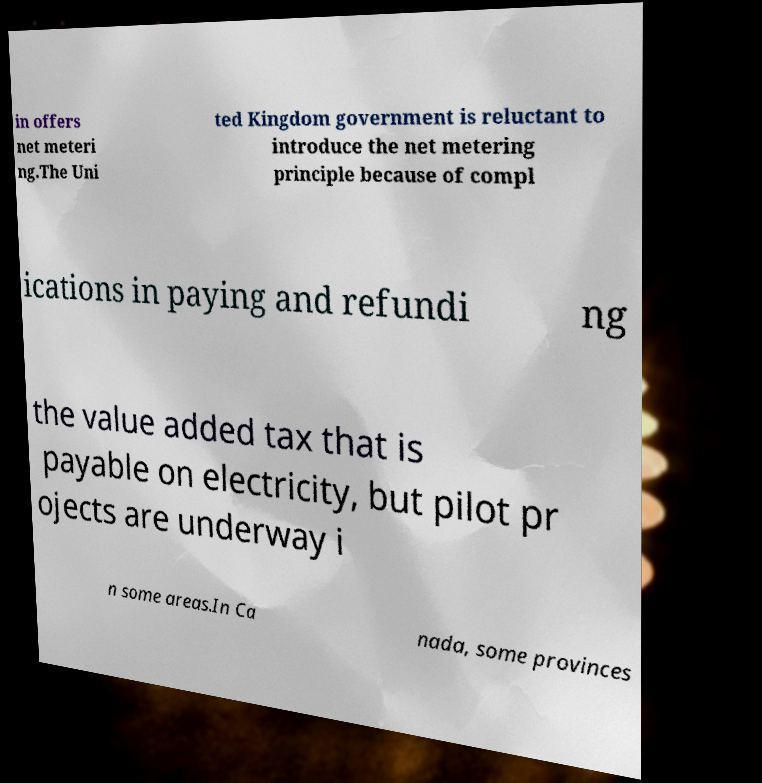I need the written content from this picture converted into text. Can you do that? in offers net meteri ng.The Uni ted Kingdom government is reluctant to introduce the net metering principle because of compl ications in paying and refundi ng the value added tax that is payable on electricity, but pilot pr ojects are underway i n some areas.In Ca nada, some provinces 